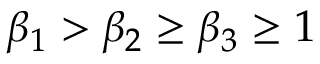<formula> <loc_0><loc_0><loc_500><loc_500>\beta _ { 1 } > \beta _ { 2 } \geq \beta _ { 3 } \geq 1</formula> 